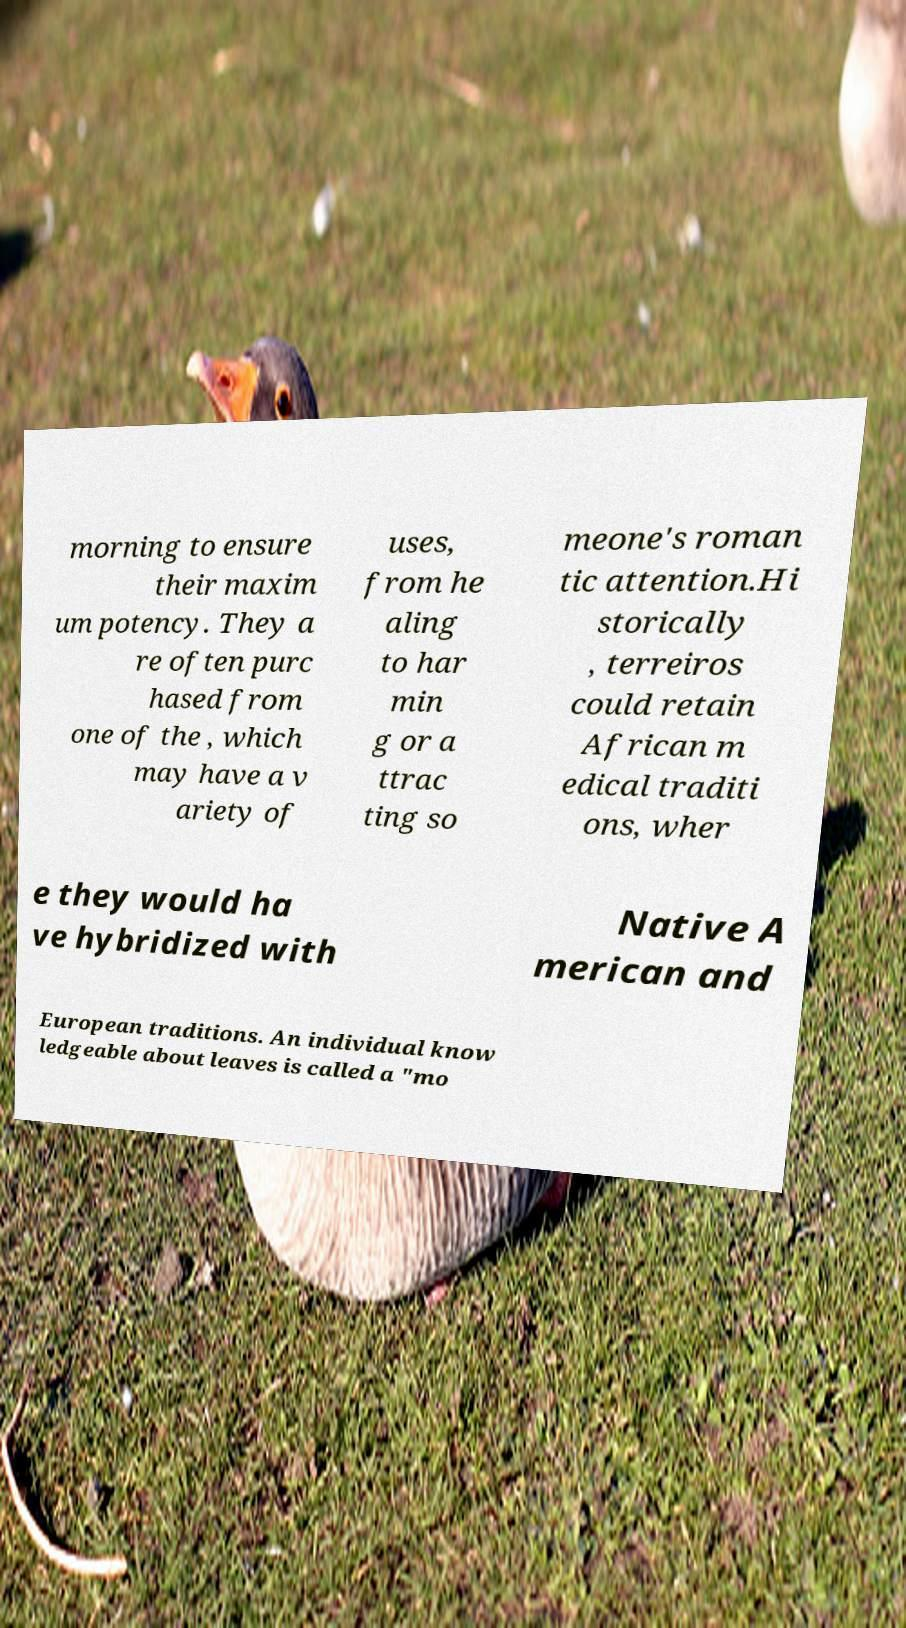Could you extract and type out the text from this image? morning to ensure their maxim um potency. They a re often purc hased from one of the , which may have a v ariety of uses, from he aling to har min g or a ttrac ting so meone's roman tic attention.Hi storically , terreiros could retain African m edical traditi ons, wher e they would ha ve hybridized with Native A merican and European traditions. An individual know ledgeable about leaves is called a "mo 